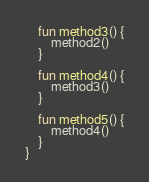<code> <loc_0><loc_0><loc_500><loc_500><_Kotlin_>
    fun method3() {
        method2()
    }

    fun method4() {
        method3()
    }

    fun method5() {
        method4()
    }
}
</code> 